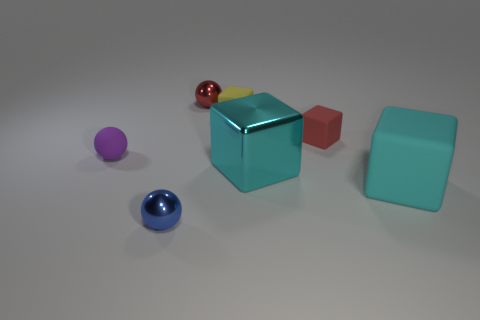Subtract all blue cubes. Subtract all yellow balls. How many cubes are left? 4 Add 2 big red matte objects. How many objects exist? 9 Subtract all blocks. How many objects are left? 3 Subtract all tiny red spheres. Subtract all tiny yellow things. How many objects are left? 5 Add 1 purple matte things. How many purple matte things are left? 2 Add 7 small purple metal balls. How many small purple metal balls exist? 7 Subtract 0 green balls. How many objects are left? 7 